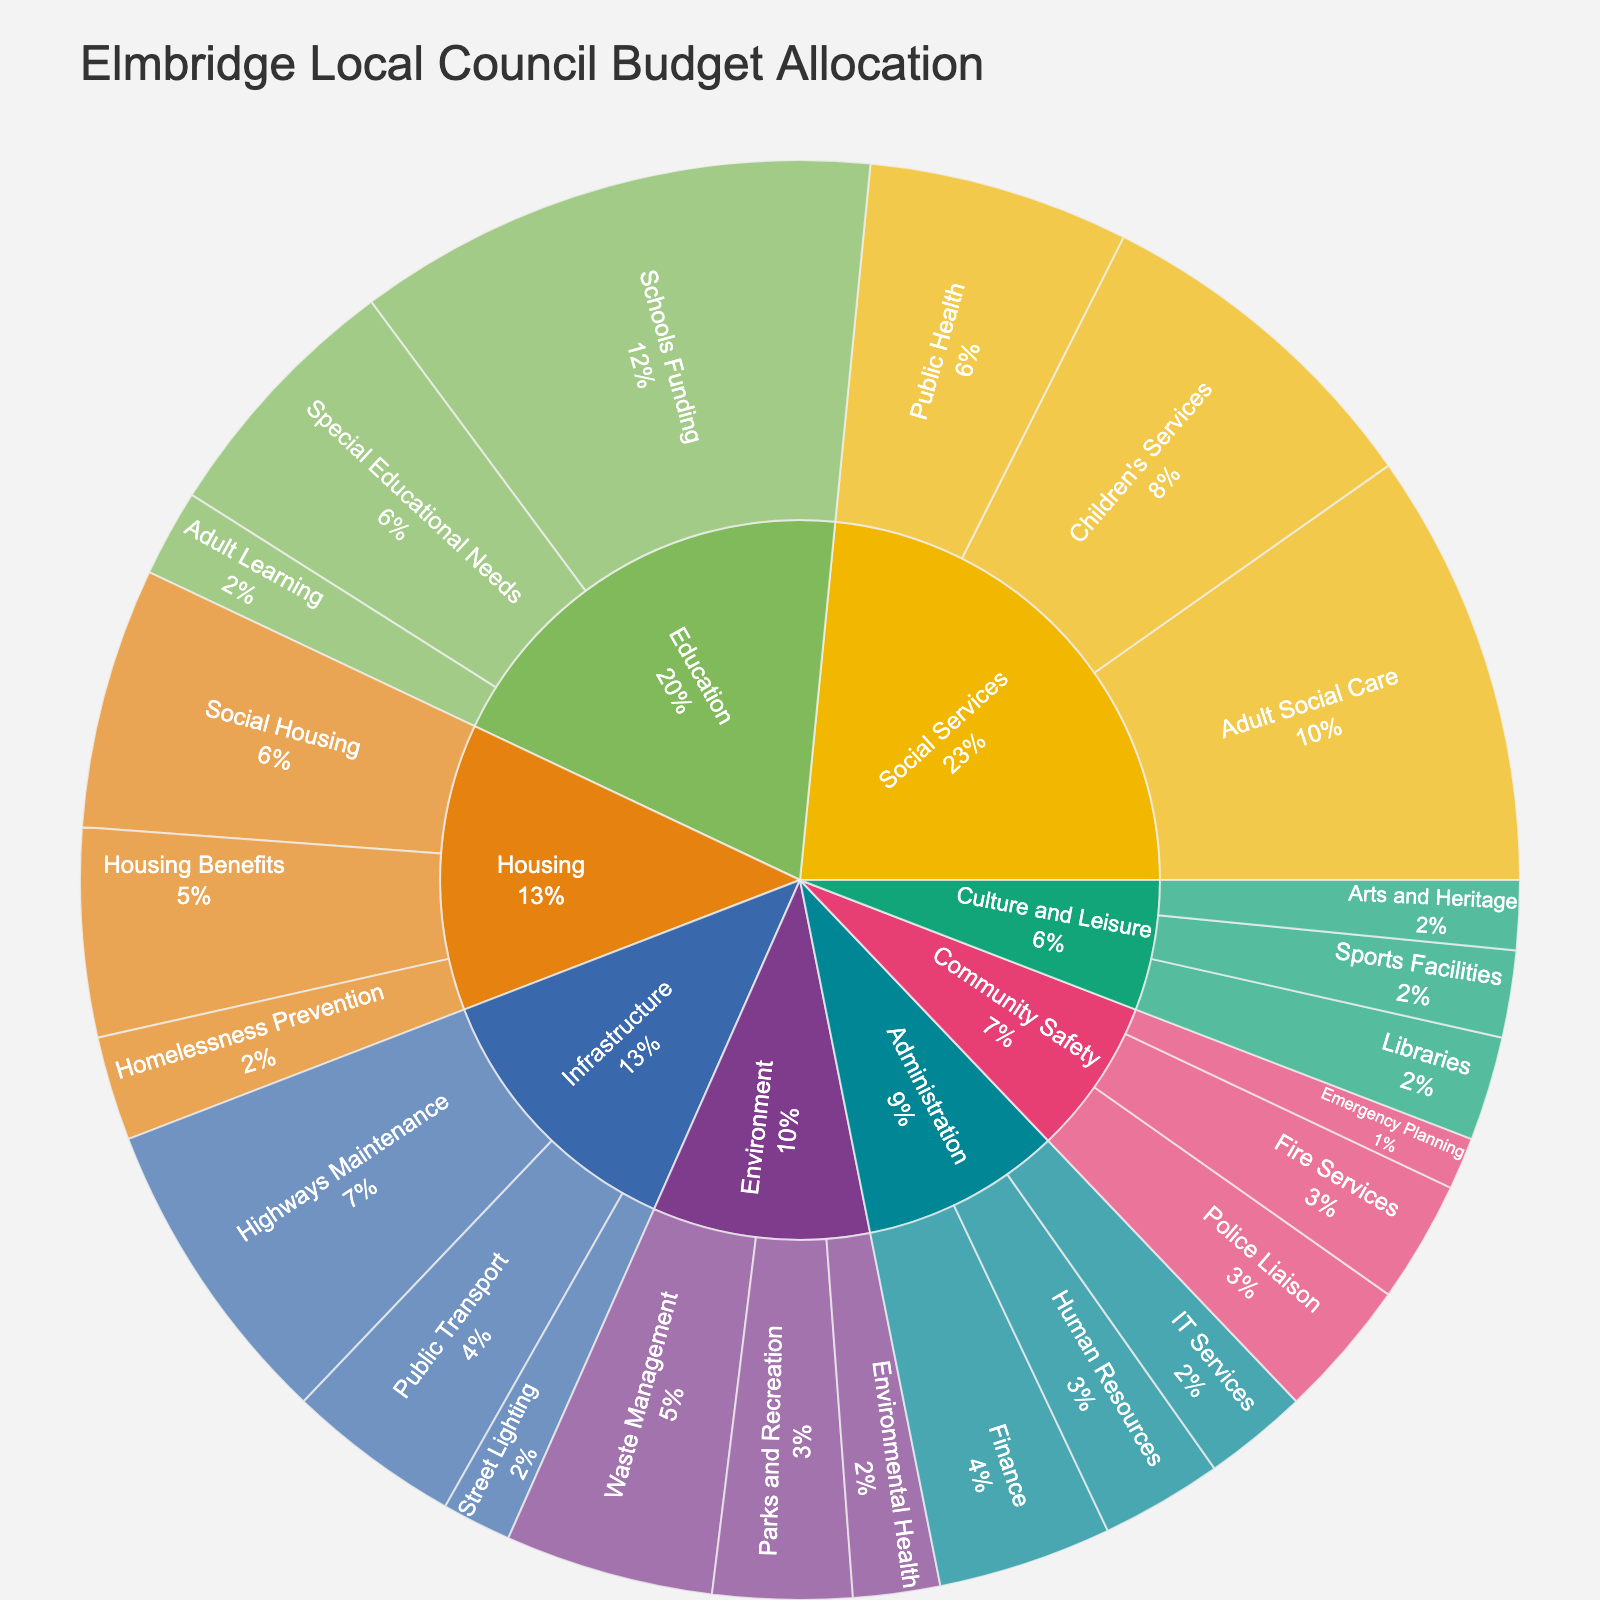What's the largest department by budget allocation? The largest department is identified by the largest slice in the sunburst plot. In this case, it is 'Education' with an allocation of £50,000,000.
Answer: Education Which sub-department in Social Services has the highest budget allocation? By looking at the breakdown under 'Social Services', 'Adult Social Care' has the highest allocation with £25,000,000.
Answer: Adult Social Care How does the budget allocation for Waste Management compare to Public Transport in Elmbridge? The sunburst plot shows 'Waste Management' under Environment with £12,000,000 and 'Public Transport' under Infrastructure with £10,000,000.
Answer: Waste Management has a higher allocation What is the total budget allocation for the Housing department? Summing the allocations for all sub-departments under Housing: £15,000,000 (Social Housing) + £12,000,000 (Housing Benefits) + £6,000,000 (Homelessness Prevention) = £33,000,000.
Answer: £33,000,000 What's the proportion of the Police Liaison budget in Community Safety? The budget for 'Police Liaison' is £8,000,000. Total Community Safety budget is £8,000,000 (Police Liaison) + £7,000,000 (Fire Services) + £3,000,000 (Emergency Planning) = £18,000,000. Proportion is £8,000,000 / £18,000,000 = 44.4%.
Answer: 44.4% Which has a higher budget, Arts and Heritage or Libraries? From the plot, 'Arts and Heritage' has a budget of £4,000,000 and 'Libraries' have £6,000,000.
Answer: Libraries Is Children's Services budget under Social Services more than the total budget for Administration? 'Children's Services' has a budget of £20,000,000 under Social Services. The total budget for Administration is £10,000,000 (Finance) + £7,000,000 (Human Resources) + £6,000,000 (IT Services) = £23,000,000.
Answer: No How much more is allocated to Schools Funding compared to Adult Learning? Schools Funding has £30,000,000 and Adult Learning has £5,000,000. The difference is £30,000,000 - £5,000,000 = £25,000,000.
Answer: £25,000,000 What percentage of the total Education budget is for Special Educational Needs? The total Education budget is £30,000,000 (Schools Funding) + £15,000,000 (Special Educational Needs) + £5,000,000 (Adult Learning) = £50,000,000. Special Educational Needs is £15,000,000 / £50,000,000 = 30%.
Answer: 30% 